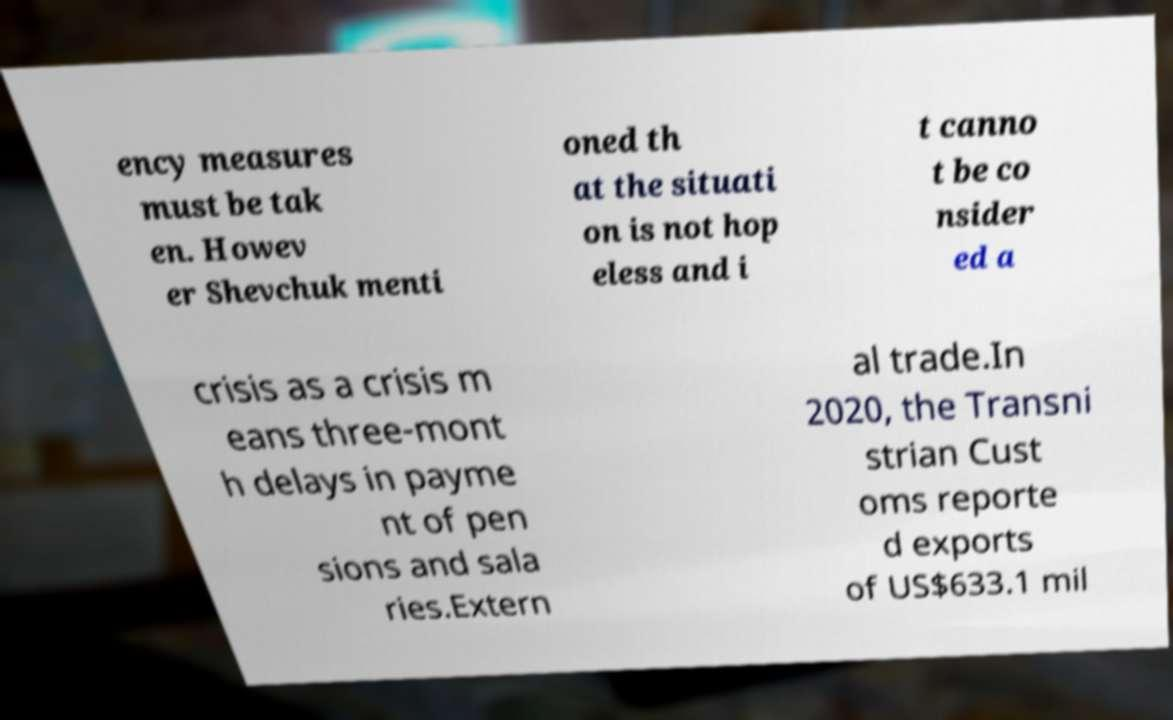Please read and relay the text visible in this image. What does it say? ency measures must be tak en. Howev er Shevchuk menti oned th at the situati on is not hop eless and i t canno t be co nsider ed a crisis as a crisis m eans three-mont h delays in payme nt of pen sions and sala ries.Extern al trade.In 2020, the Transni strian Cust oms reporte d exports of US$633.1 mil 